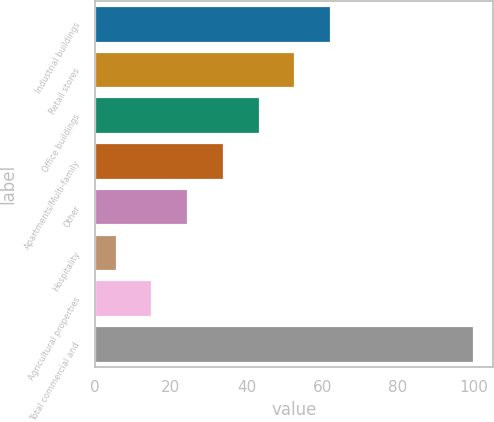<chart> <loc_0><loc_0><loc_500><loc_500><bar_chart><fcel>Industrial buildings<fcel>Retail stores<fcel>Office buildings<fcel>Apartments/Multi-family<fcel>Other<fcel>Hospitality<fcel>Agricultural properties<fcel>Total commercial and<nl><fcel>62.28<fcel>52.85<fcel>43.42<fcel>33.99<fcel>24.56<fcel>5.7<fcel>15.13<fcel>100<nl></chart> 